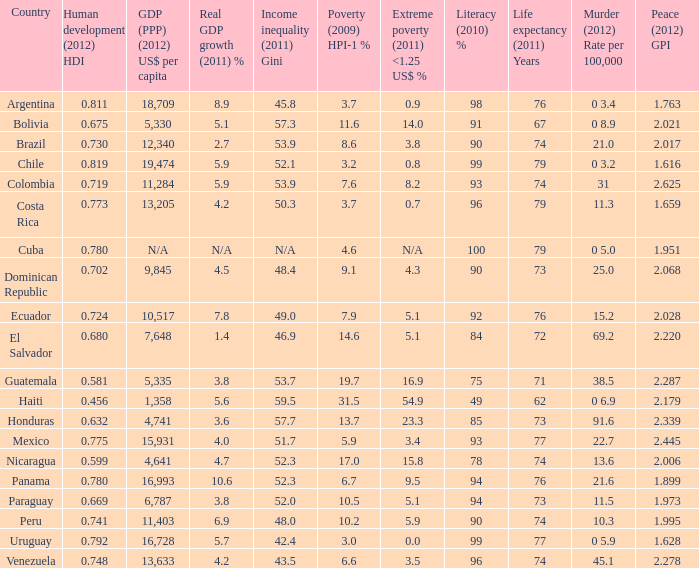What is the total poverty (2009) HPI-1 % when the extreme poverty (2011) <1.25 US$ % of 16.9, and the human development (2012) HDI is less than 0.581? None. 